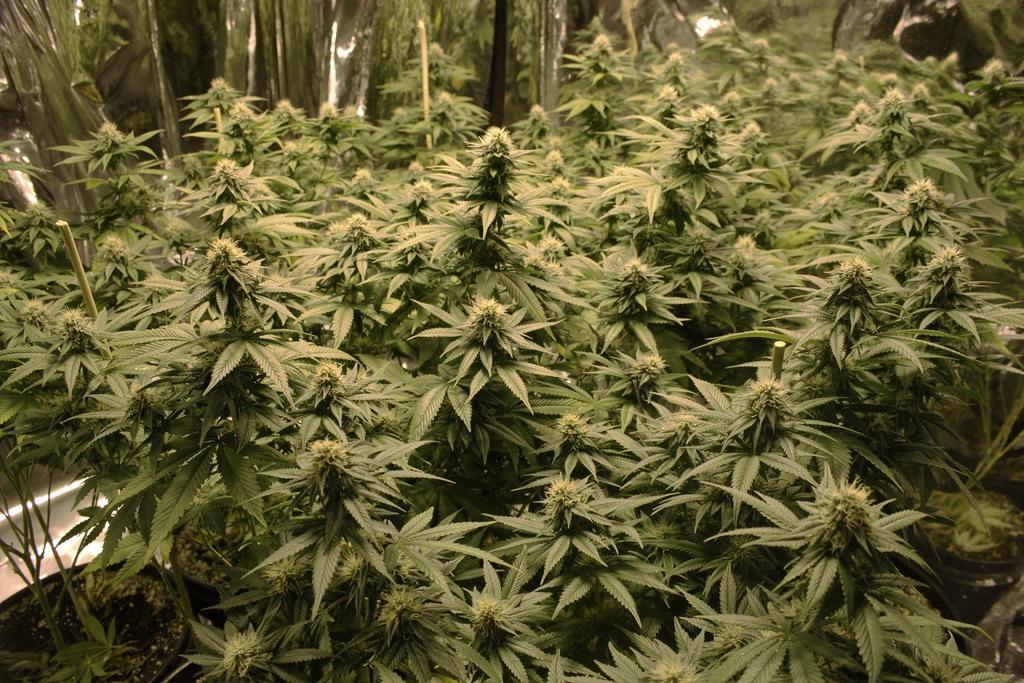Describe this image in one or two sentences. Here in this picture we can see plants and trees present all over there. 